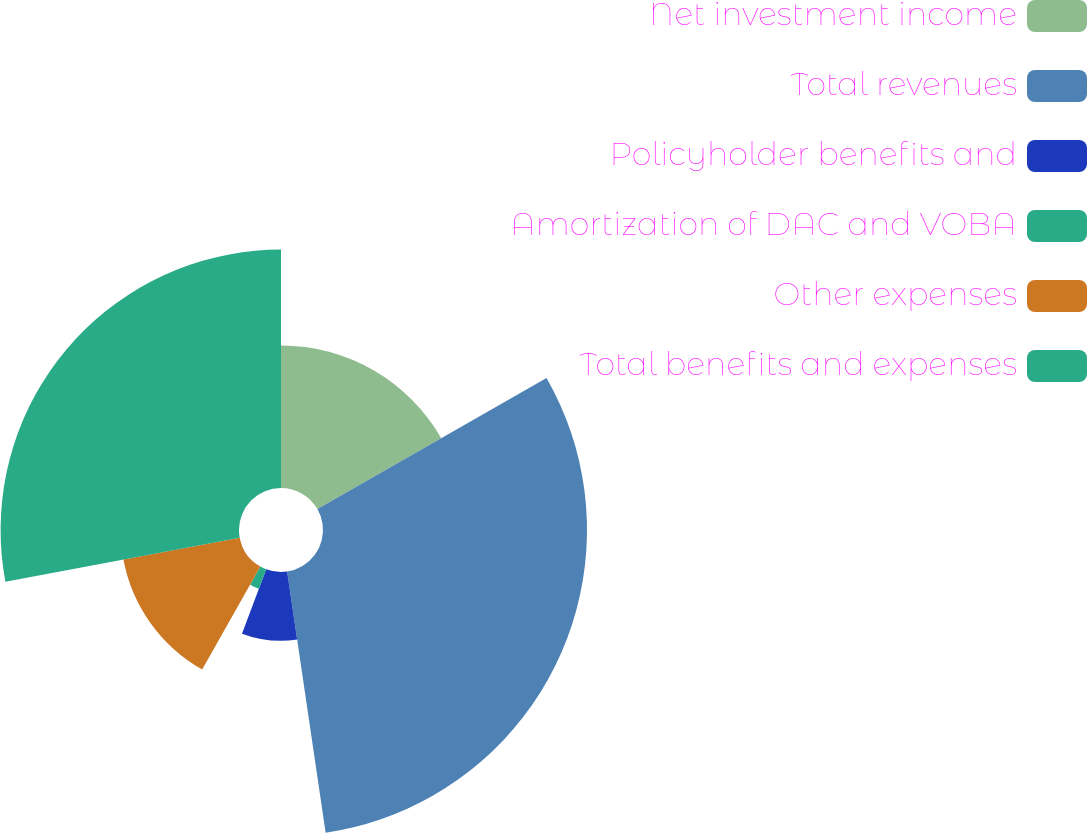Convert chart to OTSL. <chart><loc_0><loc_0><loc_500><loc_500><pie_chart><fcel>Net investment income<fcel>Total revenues<fcel>Policyholder benefits and<fcel>Amortization of DAC and VOBA<fcel>Other expenses<fcel>Total benefits and expenses<nl><fcel>16.72%<fcel>30.95%<fcel>8.06%<fcel>2.45%<fcel>13.87%<fcel>27.95%<nl></chart> 